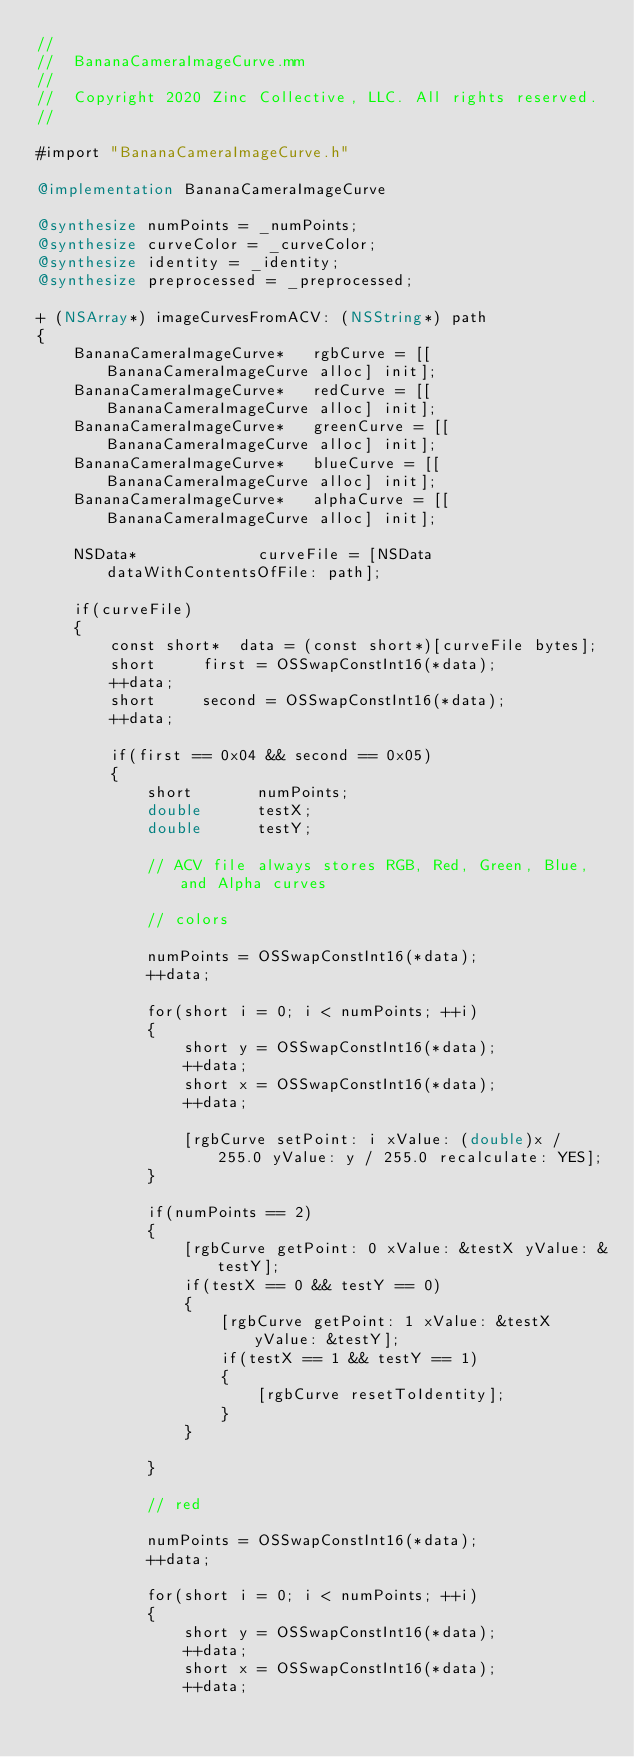Convert code to text. <code><loc_0><loc_0><loc_500><loc_500><_ObjectiveC_>//
//  BananaCameraImageCurve.mm
//
//  Copyright 2020 Zinc Collective, LLC. All rights reserved.
//

#import "BananaCameraImageCurve.h"

@implementation BananaCameraImageCurve

@synthesize numPoints = _numPoints;
@synthesize curveColor = _curveColor;
@synthesize identity = _identity;
@synthesize preprocessed = _preprocessed;

+ (NSArray*) imageCurvesFromACV: (NSString*) path
{
    BananaCameraImageCurve*   rgbCurve = [[BananaCameraImageCurve alloc] init];
    BananaCameraImageCurve*   redCurve = [[BananaCameraImageCurve alloc] init];
    BananaCameraImageCurve*   greenCurve = [[BananaCameraImageCurve alloc] init];
    BananaCameraImageCurve*   blueCurve = [[BananaCameraImageCurve alloc] init];
    BananaCameraImageCurve*   alphaCurve = [[BananaCameraImageCurve alloc] init];
    
    NSData*             curveFile = [NSData dataWithContentsOfFile: path];
    
    if(curveFile)
    {
        const short*	data = (const short*)[curveFile bytes];
        short			first = OSSwapConstInt16(*data);
        ++data;
        short			second = OSSwapConstInt16(*data);
        ++data;
        
        if(first == 0x04 && second == 0x05)
        {
            short       numPoints;
            double      testX;
            double      testY;

            // ACV file always stores RGB, Red, Green, Blue, and Alpha curves
            
            // colors
            
            numPoints = OSSwapConstInt16(*data);
            ++data;
            
            for(short i = 0; i < numPoints; ++i)
            {
                short	y = OSSwapConstInt16(*data);
                ++data;
                short	x = OSSwapConstInt16(*data);
                ++data;
                
                [rgbCurve setPoint: i xValue: (double)x / 255.0 yValue: y / 255.0 recalculate: YES];
            }
            
            if(numPoints == 2)
            {
                [rgbCurve getPoint: 0 xValue: &testX yValue: &testY];
                if(testX == 0 && testY == 0)
                {
                    [rgbCurve getPoint: 1 xValue: &testX yValue: &testY];
                    if(testX == 1 && testY == 1)
                    {
                        [rgbCurve resetToIdentity];
                    }
                }
                
            }

            // red
            
            numPoints = OSSwapConstInt16(*data);
            ++data;
            
            for(short i = 0; i < numPoints; ++i)
            {
                short	y = OSSwapConstInt16(*data);
                ++data;
                short	x = OSSwapConstInt16(*data);
                ++data;
                </code> 